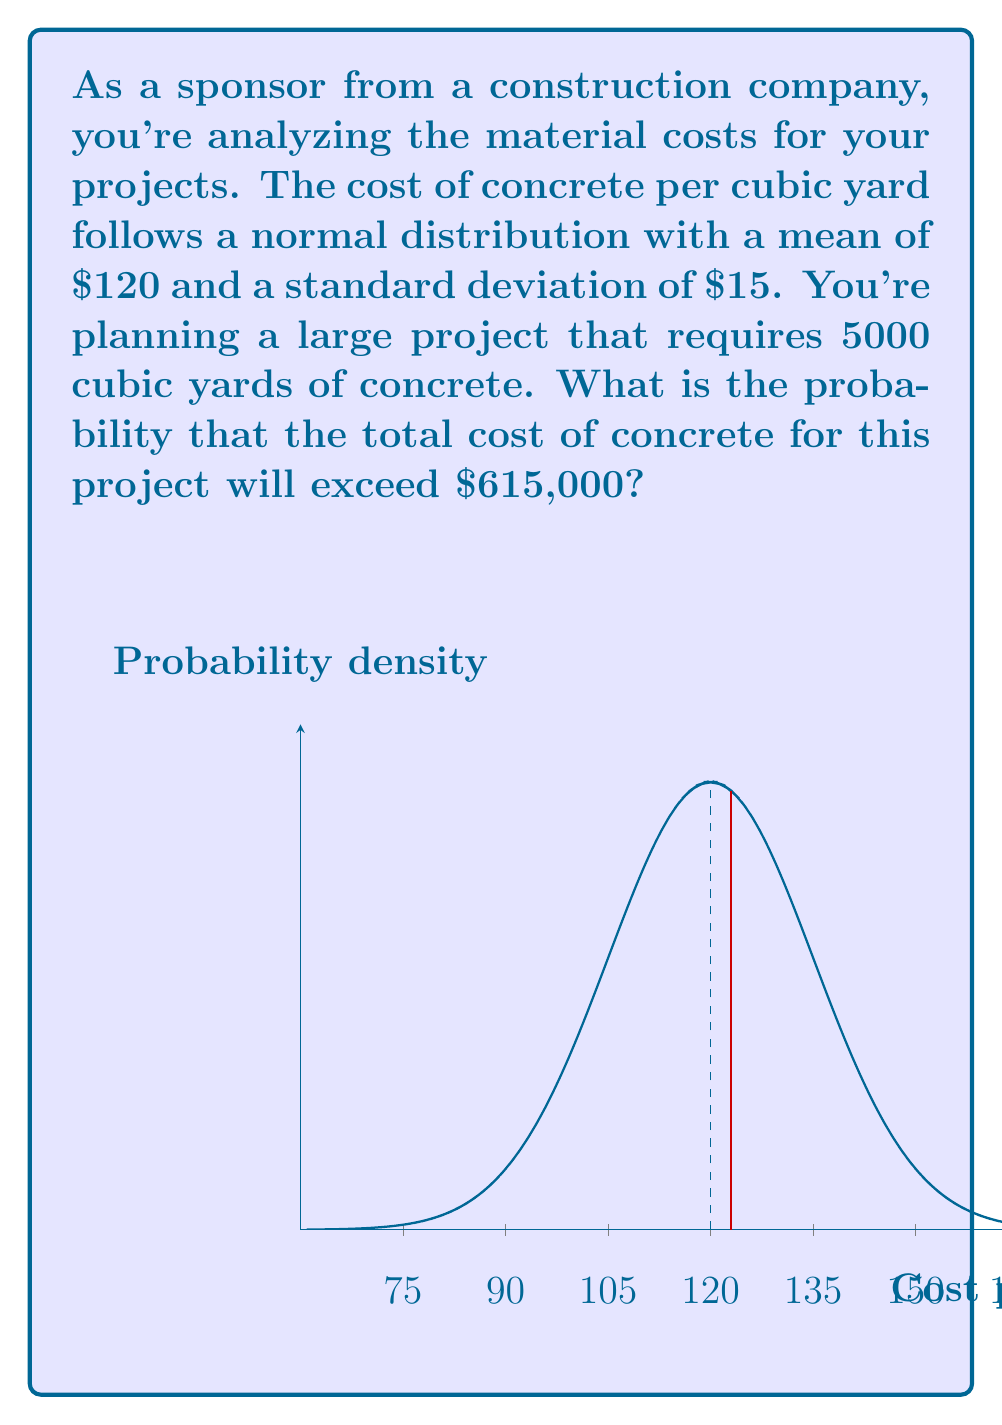Can you solve this math problem? Let's approach this step-by-step:

1) First, we need to calculate the mean total cost for 5000 cubic yards:
   $\mu_{total} = 5000 \times \$120 = \$600,000$

2) The standard deviation for the total cost:
   $\sigma_{total} = \sqrt{5000} \times \$15 = \$1060.66$

3) We want to find $P(X > 615000)$ where X is the total cost.

4) Standardize the value:
   $z = \frac{X - \mu}{\sigma} = \frac{615000 - 600000}{1060.66} = 14.14$

5) We need to find $P(Z > 14.14)$ where Z is the standard normal variable.

6) Using the standard normal table or a calculator:
   $P(Z > 14.14) \approx 0$

7) This means the probability is essentially zero (less than 0.0001).

The probability is extremely low because 615000 is more than 14 standard deviations above the mean, which is extremely rare in a normal distribution.
Answer: $\approx 0$ (less than 0.0001) 